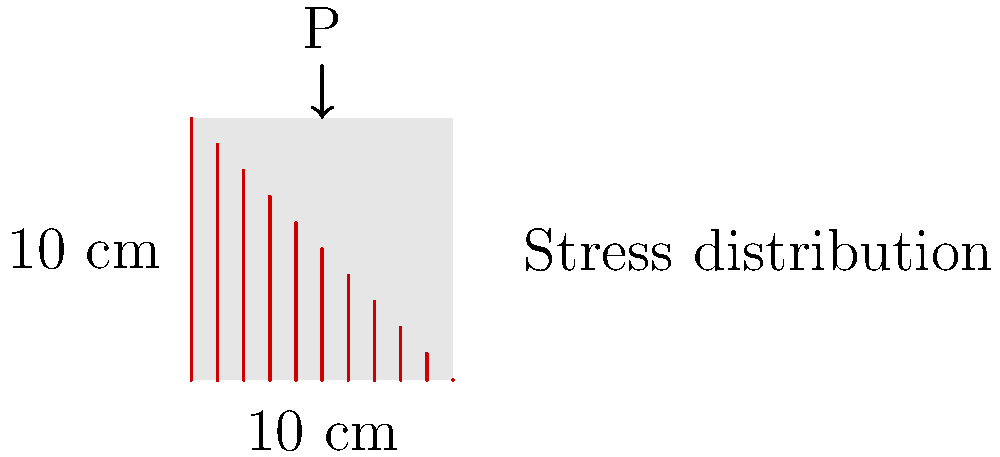Given a square concrete column with a cross-section of 10 cm x 10 cm subjected to an eccentric axial load P, as shown in the figure, determine the maximum compressive stress $\sigma_{max}$ in the column. Assume a linear stress distribution and that the neutral axis is located at the edge of the cross-section. The maximum stress occurs at the opposite edge from the neutral axis. How would you efficiently store and retrieve this stress distribution data in a filesystem? To solve this problem and consider efficient data storage, we'll follow these steps:

1) For a linear stress distribution with the neutral axis at one edge, the stress varies from 0 to $\sigma_{max}$ across the section.

2) The stress distribution can be described by the equation:
   $$\sigma(y) = \sigma_{max} \cdot \frac{y}{h}$$
   where $y$ is the distance from the neutral axis and $h$ is the section height.

3) The resultant force P must equal the integral of the stress over the area:
   $$P = \int_0^h \int_0^b \sigma(y) \cdot dx \cdot dy$$
   where $b$ is the section width.

4) Substituting and solving:
   $$P = \int_0^{10} \int_0^{10} \sigma_{max} \cdot \frac{y}{10} \cdot dx \cdot dy$$
   $$P = \sigma_{max} \cdot \frac{10}{2} \cdot 10 = 50\sigma_{max}$$

5) Rearranging:
   $$\sigma_{max} = \frac{P}{50}$$

6) For efficient data storage and retrieval in a filesystem:
   - Store the stress distribution as a function rather than discrete values.
   - Use a serialization format like JSON or Protocol Buffers to store the function parameters (e.g., $\sigma_{max}$ and column dimensions).
   - Implement a caching mechanism to store frequently accessed stress distributions.
   - Use indexing based on column properties for quick lookup.
   - Consider using a columnar storage format for efficient querying of specific stress values.

This approach allows for compact storage and fast retrieval, which is crucial for a filesystem designed for engineering applications.
Answer: $\sigma_{max} = \frac{P}{50}$; Store as function parameters in serialized format with indexed lookup. 